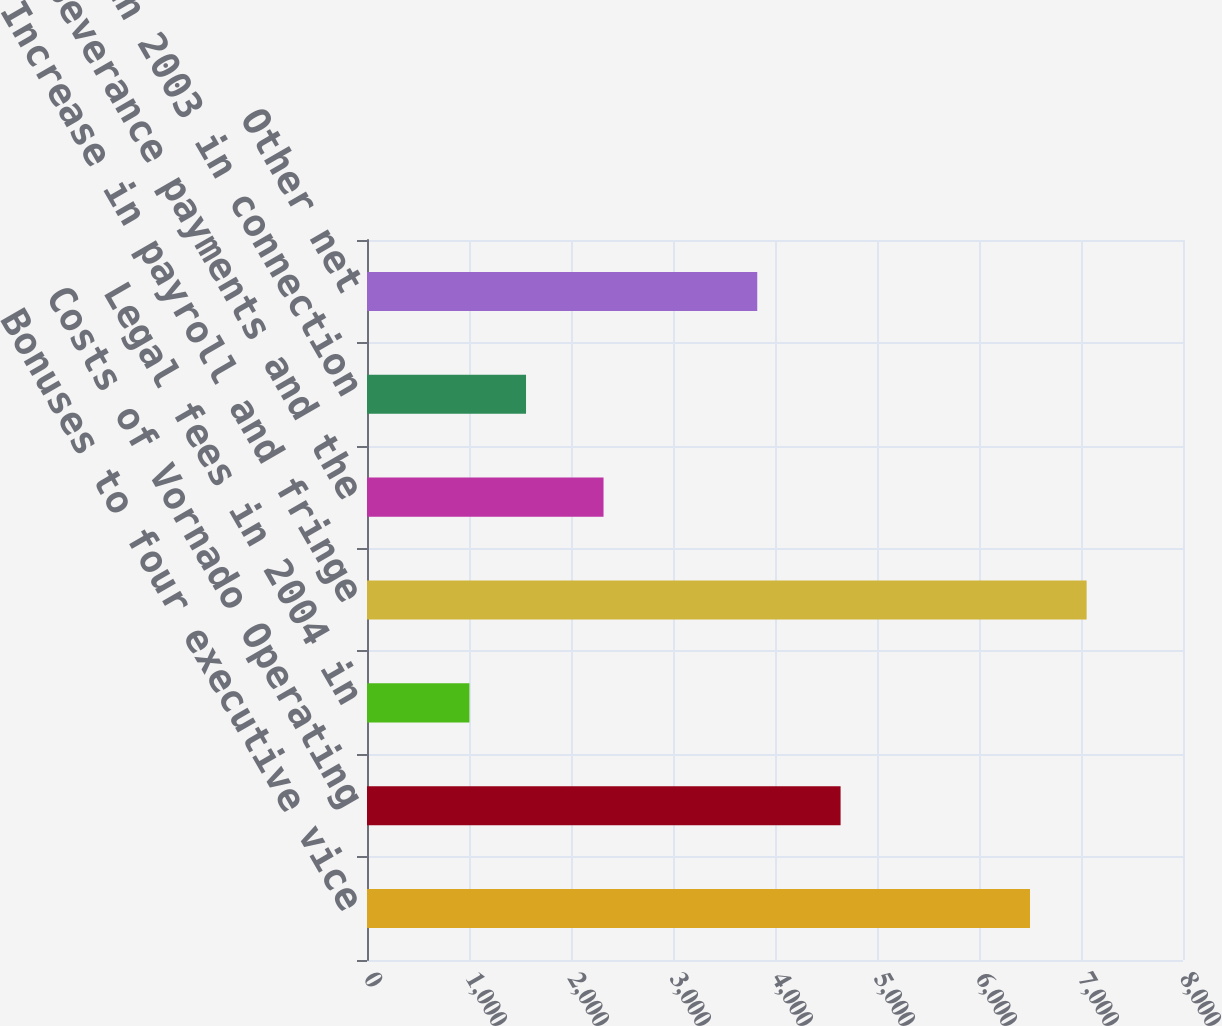Convert chart to OTSL. <chart><loc_0><loc_0><loc_500><loc_500><bar_chart><fcel>Bonuses to four executive vice<fcel>Costs of Vornado Operating<fcel>Legal fees in 2004 in<fcel>Increase in payroll and fringe<fcel>Severance payments and the<fcel>Costs in 2003 in connection<fcel>Other net<nl><fcel>6500<fcel>4643<fcel>1004<fcel>7055.1<fcel>2319<fcel>1559.1<fcel>3826<nl></chart> 